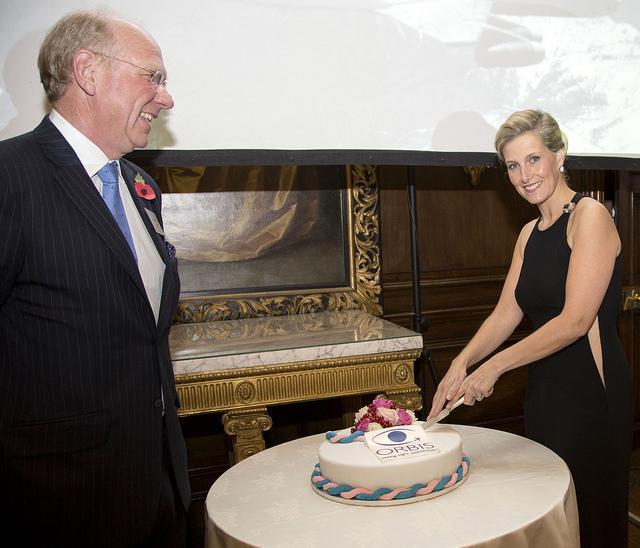How many people are there?
Give a very brief answer. 2. How many dining tables are in the picture?
Give a very brief answer. 1. 